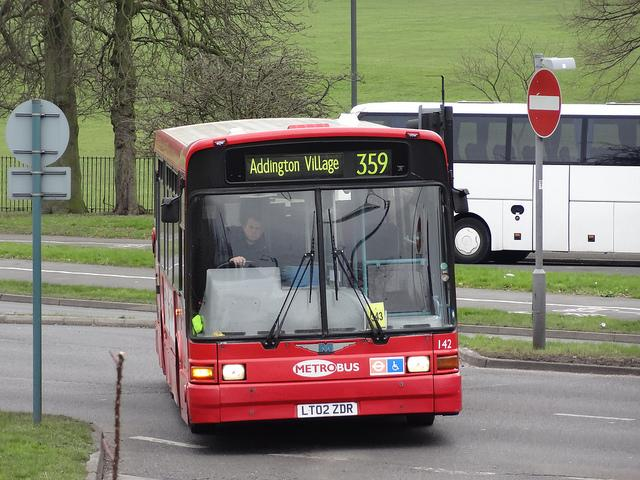What type of information is on the digital bus sign? destination city 